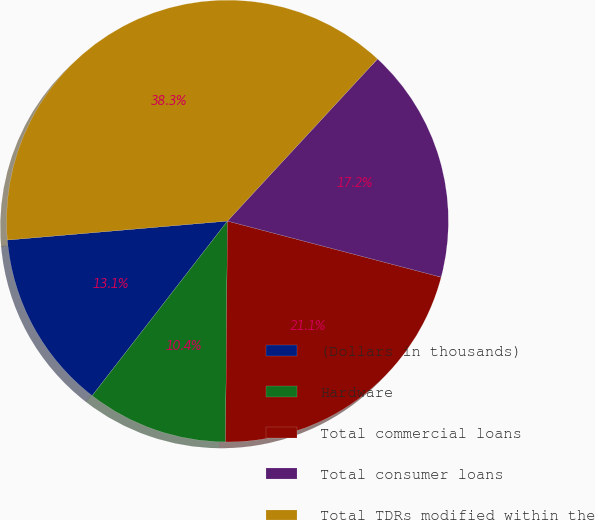Convert chart. <chart><loc_0><loc_0><loc_500><loc_500><pie_chart><fcel>(Dollars in thousands)<fcel>Hardware<fcel>Total commercial loans<fcel>Total consumer loans<fcel>Total TDRs modified within the<nl><fcel>13.14%<fcel>10.35%<fcel>21.05%<fcel>17.2%<fcel>38.25%<nl></chart> 